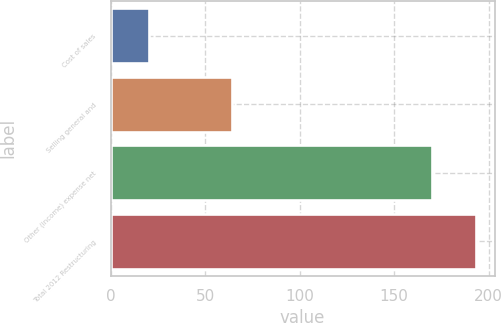<chart> <loc_0><loc_0><loc_500><loc_500><bar_chart><fcel>Cost of sales<fcel>Selling general and<fcel>Other (income) expense net<fcel>Total 2012 Restructuring<nl><fcel>20<fcel>64<fcel>170<fcel>193.4<nl></chart> 